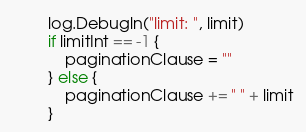Convert code to text. <code><loc_0><loc_0><loc_500><loc_500><_Go_>		log.Debugln("limit: ", limit)
		if limitInt == -1 {
			paginationClause = ""
		} else {
			paginationClause += " " + limit
		}</code> 